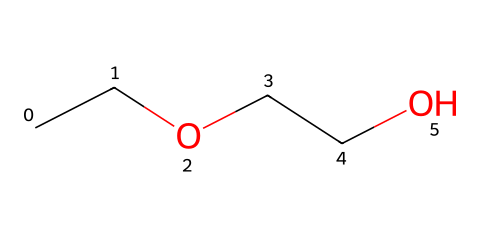How many carbon atoms are in ethylene glycol monoethyl ether? The SMILES representation "CCOCCO" reveals the structure contains four carbon atoms, as indicated by the presence of 'C' in two pairs and each 'CC' represents two carbon atoms linked together.
Answer: four What is the functional group present in ethylene glycol monoethyl ether? The presence of the 'O' atoms in the SMILES representation indicates the existence of ether functional groups since ethers typically consist of an oxygen atom bonded to two carbon containing groups.
Answer: ether How many oxygen atoms are present in this chemical structure? By examining the SMILES notation "CCOCCO", we can count two 'O' characters which confirm the presence of two oxygen atoms in the structure.
Answer: two What type of chemical is ethylene glycol monoethyl ether classified as? Given its structure composed of carbon, hydrogen, and oxygen, and the presence of the ether functional group, it is classified as an ether due to its structure fitting the ether criteria.
Answer: ether Is ethylene glycol monoethyl ether polar or nonpolar? The presence of hydroxyl groups (derived from the ether structure) indicates that the compound has polar characteristics due to the electronegative oxygen atoms, contributing to a polar nature overall.
Answer: polar What is the total number of hydrogen atoms in ethylene glycol monoethyl ether? Each carbon typically can form four bonds, and when considering the structure shown in the SMILES notation, we count a total of ten hydrogen atoms necessary to satisfy the tetravalency of the four carbon atoms in the structure.
Answer: ten 